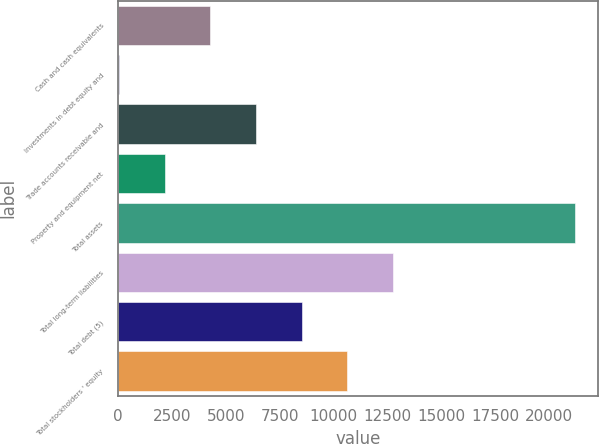<chart> <loc_0><loc_0><loc_500><loc_500><bar_chart><fcel>Cash and cash equivalents<fcel>Investments in debt equity and<fcel>Trade accounts receivable and<fcel>Property and equipment net<fcel>Total assets<fcel>Total long-term liabilities<fcel>Total debt (5)<fcel>Total stockholders ' equity<nl><fcel>4284<fcel>53<fcel>6399.5<fcel>2168.5<fcel>21208<fcel>12746<fcel>8515<fcel>10630.5<nl></chart> 